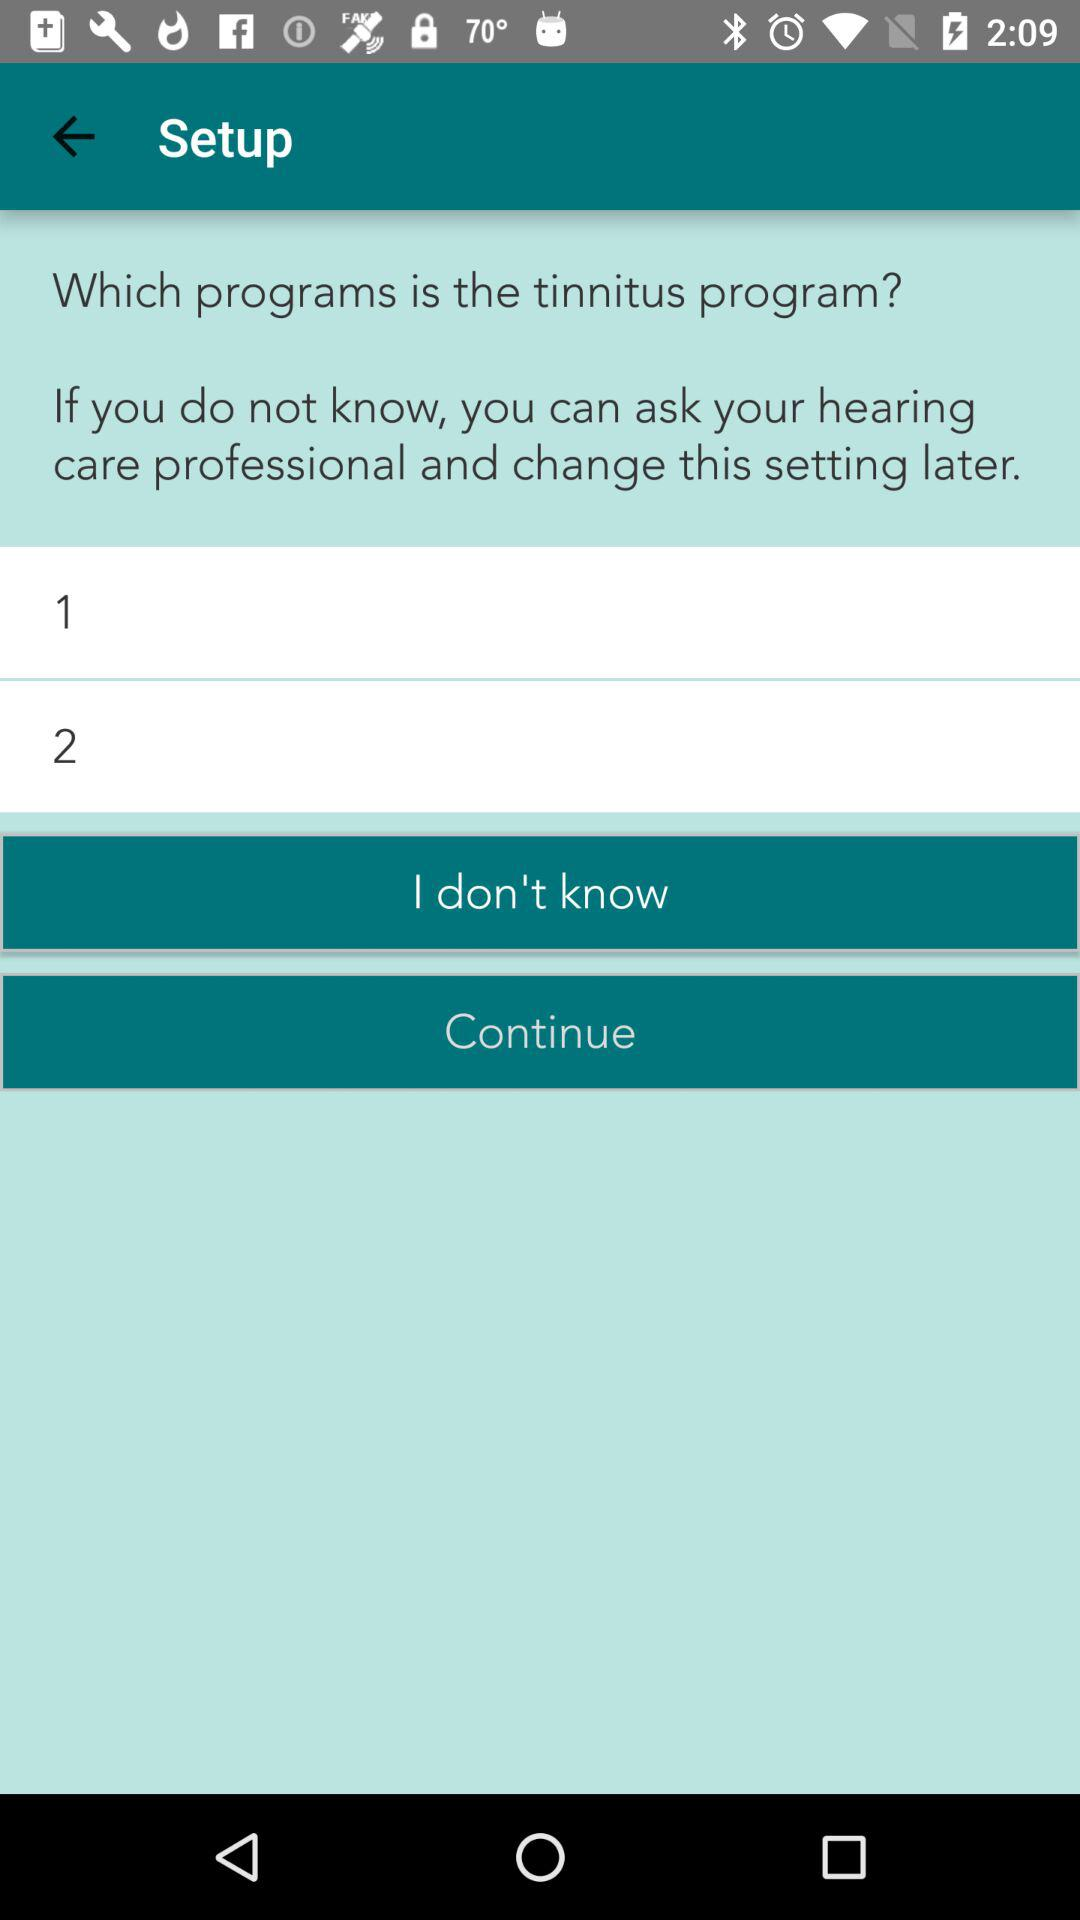How many options are available for the tinnitus program?
Answer the question using a single word or phrase. 2 